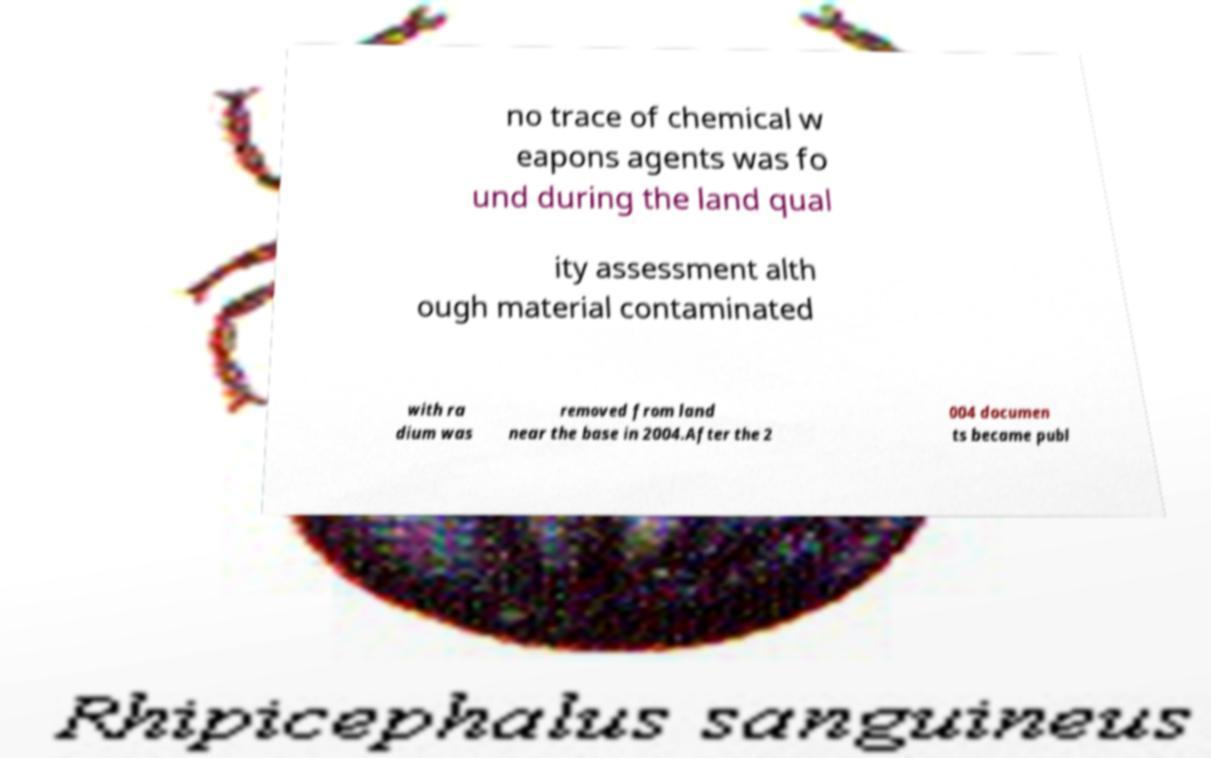Please identify and transcribe the text found in this image. no trace of chemical w eapons agents was fo und during the land qual ity assessment alth ough material contaminated with ra dium was removed from land near the base in 2004.After the 2 004 documen ts became publ 